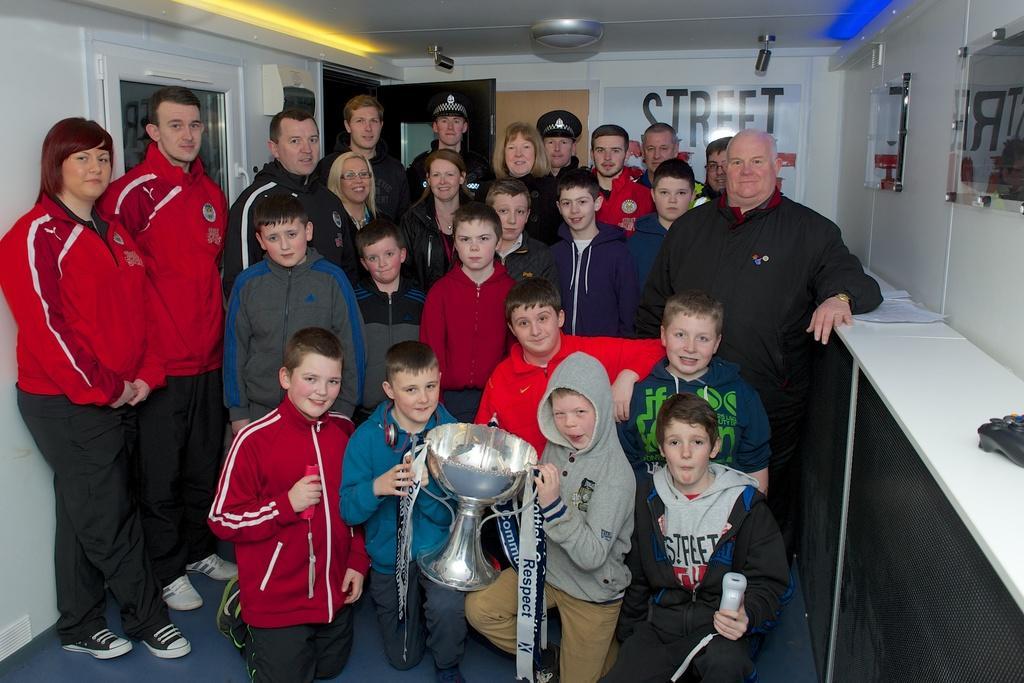In one or two sentences, can you explain what this image depicts? In the center of the image we can see some people are standing and wearing the jackets and some of them are sitting on their knees and two boys are holding a trophy and another boy is holding an object. In the background of the image we can see the doors, boards on the wall, mirrors. At the top of the image we can see the roof and lights. At the bottom of the image we can see the floor. On the right side of the image we can see the cupboards, papers and object. 